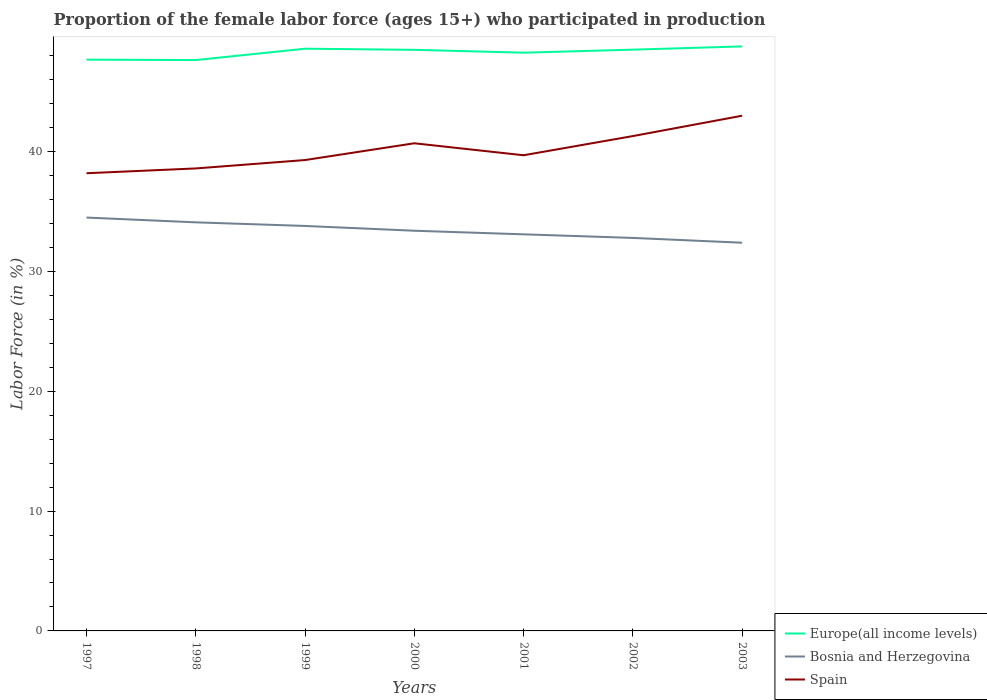How many different coloured lines are there?
Your response must be concise. 3. Across all years, what is the maximum proportion of the female labor force who participated in production in Spain?
Make the answer very short. 38.2. What is the total proportion of the female labor force who participated in production in Bosnia and Herzegovina in the graph?
Give a very brief answer. 0.3. What is the difference between the highest and the second highest proportion of the female labor force who participated in production in Europe(all income levels)?
Provide a succinct answer. 1.14. Is the proportion of the female labor force who participated in production in Bosnia and Herzegovina strictly greater than the proportion of the female labor force who participated in production in Spain over the years?
Provide a succinct answer. Yes. How many lines are there?
Provide a short and direct response. 3. What is the difference between two consecutive major ticks on the Y-axis?
Your answer should be compact. 10. Does the graph contain grids?
Keep it short and to the point. No. Where does the legend appear in the graph?
Offer a very short reply. Bottom right. How many legend labels are there?
Provide a short and direct response. 3. What is the title of the graph?
Make the answer very short. Proportion of the female labor force (ages 15+) who participated in production. What is the label or title of the Y-axis?
Provide a succinct answer. Labor Force (in %). What is the Labor Force (in %) in Europe(all income levels) in 1997?
Offer a very short reply. 47.68. What is the Labor Force (in %) in Bosnia and Herzegovina in 1997?
Offer a terse response. 34.5. What is the Labor Force (in %) in Spain in 1997?
Your answer should be very brief. 38.2. What is the Labor Force (in %) in Europe(all income levels) in 1998?
Your answer should be very brief. 47.65. What is the Labor Force (in %) of Bosnia and Herzegovina in 1998?
Provide a succinct answer. 34.1. What is the Labor Force (in %) in Spain in 1998?
Offer a very short reply. 38.6. What is the Labor Force (in %) in Europe(all income levels) in 1999?
Offer a very short reply. 48.59. What is the Labor Force (in %) of Bosnia and Herzegovina in 1999?
Offer a very short reply. 33.8. What is the Labor Force (in %) of Spain in 1999?
Provide a succinct answer. 39.3. What is the Labor Force (in %) in Europe(all income levels) in 2000?
Make the answer very short. 48.5. What is the Labor Force (in %) in Bosnia and Herzegovina in 2000?
Your answer should be very brief. 33.4. What is the Labor Force (in %) of Spain in 2000?
Your response must be concise. 40.7. What is the Labor Force (in %) in Europe(all income levels) in 2001?
Provide a short and direct response. 48.26. What is the Labor Force (in %) in Bosnia and Herzegovina in 2001?
Make the answer very short. 33.1. What is the Labor Force (in %) of Spain in 2001?
Make the answer very short. 39.7. What is the Labor Force (in %) of Europe(all income levels) in 2002?
Give a very brief answer. 48.51. What is the Labor Force (in %) in Bosnia and Herzegovina in 2002?
Keep it short and to the point. 32.8. What is the Labor Force (in %) of Spain in 2002?
Provide a short and direct response. 41.3. What is the Labor Force (in %) of Europe(all income levels) in 2003?
Give a very brief answer. 48.79. What is the Labor Force (in %) of Bosnia and Herzegovina in 2003?
Provide a succinct answer. 32.4. Across all years, what is the maximum Labor Force (in %) of Europe(all income levels)?
Make the answer very short. 48.79. Across all years, what is the maximum Labor Force (in %) of Bosnia and Herzegovina?
Ensure brevity in your answer.  34.5. Across all years, what is the minimum Labor Force (in %) in Europe(all income levels)?
Offer a terse response. 47.65. Across all years, what is the minimum Labor Force (in %) in Bosnia and Herzegovina?
Make the answer very short. 32.4. Across all years, what is the minimum Labor Force (in %) in Spain?
Your answer should be very brief. 38.2. What is the total Labor Force (in %) in Europe(all income levels) in the graph?
Ensure brevity in your answer.  337.98. What is the total Labor Force (in %) of Bosnia and Herzegovina in the graph?
Your answer should be very brief. 234.1. What is the total Labor Force (in %) of Spain in the graph?
Ensure brevity in your answer.  280.8. What is the difference between the Labor Force (in %) of Europe(all income levels) in 1997 and that in 1998?
Keep it short and to the point. 0.04. What is the difference between the Labor Force (in %) in Bosnia and Herzegovina in 1997 and that in 1998?
Your response must be concise. 0.4. What is the difference between the Labor Force (in %) of Europe(all income levels) in 1997 and that in 1999?
Offer a very short reply. -0.91. What is the difference between the Labor Force (in %) of Spain in 1997 and that in 1999?
Ensure brevity in your answer.  -1.1. What is the difference between the Labor Force (in %) of Europe(all income levels) in 1997 and that in 2000?
Provide a succinct answer. -0.82. What is the difference between the Labor Force (in %) of Spain in 1997 and that in 2000?
Your response must be concise. -2.5. What is the difference between the Labor Force (in %) in Europe(all income levels) in 1997 and that in 2001?
Make the answer very short. -0.58. What is the difference between the Labor Force (in %) of Bosnia and Herzegovina in 1997 and that in 2001?
Provide a succinct answer. 1.4. What is the difference between the Labor Force (in %) of Europe(all income levels) in 1997 and that in 2002?
Provide a short and direct response. -0.83. What is the difference between the Labor Force (in %) in Bosnia and Herzegovina in 1997 and that in 2002?
Provide a succinct answer. 1.7. What is the difference between the Labor Force (in %) of Spain in 1997 and that in 2002?
Offer a very short reply. -3.1. What is the difference between the Labor Force (in %) in Europe(all income levels) in 1997 and that in 2003?
Make the answer very short. -1.11. What is the difference between the Labor Force (in %) of Europe(all income levels) in 1998 and that in 1999?
Your answer should be very brief. -0.95. What is the difference between the Labor Force (in %) in Bosnia and Herzegovina in 1998 and that in 1999?
Make the answer very short. 0.3. What is the difference between the Labor Force (in %) of Europe(all income levels) in 1998 and that in 2000?
Provide a succinct answer. -0.85. What is the difference between the Labor Force (in %) in Europe(all income levels) in 1998 and that in 2001?
Keep it short and to the point. -0.62. What is the difference between the Labor Force (in %) of Europe(all income levels) in 1998 and that in 2002?
Provide a succinct answer. -0.87. What is the difference between the Labor Force (in %) of Spain in 1998 and that in 2002?
Offer a terse response. -2.7. What is the difference between the Labor Force (in %) of Europe(all income levels) in 1998 and that in 2003?
Keep it short and to the point. -1.14. What is the difference between the Labor Force (in %) of Spain in 1998 and that in 2003?
Provide a short and direct response. -4.4. What is the difference between the Labor Force (in %) of Europe(all income levels) in 1999 and that in 2000?
Make the answer very short. 0.1. What is the difference between the Labor Force (in %) in Europe(all income levels) in 1999 and that in 2001?
Keep it short and to the point. 0.33. What is the difference between the Labor Force (in %) of Spain in 1999 and that in 2001?
Your answer should be very brief. -0.4. What is the difference between the Labor Force (in %) in Europe(all income levels) in 1999 and that in 2002?
Provide a succinct answer. 0.08. What is the difference between the Labor Force (in %) in Bosnia and Herzegovina in 1999 and that in 2002?
Offer a terse response. 1. What is the difference between the Labor Force (in %) in Europe(all income levels) in 1999 and that in 2003?
Provide a succinct answer. -0.19. What is the difference between the Labor Force (in %) in Bosnia and Herzegovina in 1999 and that in 2003?
Ensure brevity in your answer.  1.4. What is the difference between the Labor Force (in %) of Spain in 1999 and that in 2003?
Make the answer very short. -3.7. What is the difference between the Labor Force (in %) of Europe(all income levels) in 2000 and that in 2001?
Offer a terse response. 0.24. What is the difference between the Labor Force (in %) in Bosnia and Herzegovina in 2000 and that in 2001?
Offer a terse response. 0.3. What is the difference between the Labor Force (in %) of Spain in 2000 and that in 2001?
Your response must be concise. 1. What is the difference between the Labor Force (in %) in Europe(all income levels) in 2000 and that in 2002?
Make the answer very short. -0.02. What is the difference between the Labor Force (in %) of Bosnia and Herzegovina in 2000 and that in 2002?
Give a very brief answer. 0.6. What is the difference between the Labor Force (in %) of Spain in 2000 and that in 2002?
Ensure brevity in your answer.  -0.6. What is the difference between the Labor Force (in %) in Europe(all income levels) in 2000 and that in 2003?
Ensure brevity in your answer.  -0.29. What is the difference between the Labor Force (in %) of Spain in 2000 and that in 2003?
Provide a succinct answer. -2.3. What is the difference between the Labor Force (in %) in Europe(all income levels) in 2001 and that in 2002?
Make the answer very short. -0.25. What is the difference between the Labor Force (in %) of Bosnia and Herzegovina in 2001 and that in 2002?
Give a very brief answer. 0.3. What is the difference between the Labor Force (in %) in Europe(all income levels) in 2001 and that in 2003?
Give a very brief answer. -0.52. What is the difference between the Labor Force (in %) of Bosnia and Herzegovina in 2001 and that in 2003?
Your answer should be very brief. 0.7. What is the difference between the Labor Force (in %) of Spain in 2001 and that in 2003?
Give a very brief answer. -3.3. What is the difference between the Labor Force (in %) of Europe(all income levels) in 2002 and that in 2003?
Offer a very short reply. -0.27. What is the difference between the Labor Force (in %) of Europe(all income levels) in 1997 and the Labor Force (in %) of Bosnia and Herzegovina in 1998?
Offer a terse response. 13.58. What is the difference between the Labor Force (in %) in Europe(all income levels) in 1997 and the Labor Force (in %) in Spain in 1998?
Your response must be concise. 9.08. What is the difference between the Labor Force (in %) in Europe(all income levels) in 1997 and the Labor Force (in %) in Bosnia and Herzegovina in 1999?
Give a very brief answer. 13.88. What is the difference between the Labor Force (in %) in Europe(all income levels) in 1997 and the Labor Force (in %) in Spain in 1999?
Ensure brevity in your answer.  8.38. What is the difference between the Labor Force (in %) of Bosnia and Herzegovina in 1997 and the Labor Force (in %) of Spain in 1999?
Make the answer very short. -4.8. What is the difference between the Labor Force (in %) in Europe(all income levels) in 1997 and the Labor Force (in %) in Bosnia and Herzegovina in 2000?
Your answer should be compact. 14.28. What is the difference between the Labor Force (in %) of Europe(all income levels) in 1997 and the Labor Force (in %) of Spain in 2000?
Offer a very short reply. 6.98. What is the difference between the Labor Force (in %) of Europe(all income levels) in 1997 and the Labor Force (in %) of Bosnia and Herzegovina in 2001?
Make the answer very short. 14.58. What is the difference between the Labor Force (in %) of Europe(all income levels) in 1997 and the Labor Force (in %) of Spain in 2001?
Offer a terse response. 7.98. What is the difference between the Labor Force (in %) of Europe(all income levels) in 1997 and the Labor Force (in %) of Bosnia and Herzegovina in 2002?
Give a very brief answer. 14.88. What is the difference between the Labor Force (in %) of Europe(all income levels) in 1997 and the Labor Force (in %) of Spain in 2002?
Give a very brief answer. 6.38. What is the difference between the Labor Force (in %) in Europe(all income levels) in 1997 and the Labor Force (in %) in Bosnia and Herzegovina in 2003?
Keep it short and to the point. 15.28. What is the difference between the Labor Force (in %) of Europe(all income levels) in 1997 and the Labor Force (in %) of Spain in 2003?
Your answer should be very brief. 4.68. What is the difference between the Labor Force (in %) of Europe(all income levels) in 1998 and the Labor Force (in %) of Bosnia and Herzegovina in 1999?
Make the answer very short. 13.85. What is the difference between the Labor Force (in %) of Europe(all income levels) in 1998 and the Labor Force (in %) of Spain in 1999?
Your answer should be compact. 8.35. What is the difference between the Labor Force (in %) in Bosnia and Herzegovina in 1998 and the Labor Force (in %) in Spain in 1999?
Offer a terse response. -5.2. What is the difference between the Labor Force (in %) in Europe(all income levels) in 1998 and the Labor Force (in %) in Bosnia and Herzegovina in 2000?
Keep it short and to the point. 14.25. What is the difference between the Labor Force (in %) in Europe(all income levels) in 1998 and the Labor Force (in %) in Spain in 2000?
Keep it short and to the point. 6.95. What is the difference between the Labor Force (in %) in Europe(all income levels) in 1998 and the Labor Force (in %) in Bosnia and Herzegovina in 2001?
Your answer should be very brief. 14.55. What is the difference between the Labor Force (in %) in Europe(all income levels) in 1998 and the Labor Force (in %) in Spain in 2001?
Provide a short and direct response. 7.95. What is the difference between the Labor Force (in %) in Europe(all income levels) in 1998 and the Labor Force (in %) in Bosnia and Herzegovina in 2002?
Ensure brevity in your answer.  14.85. What is the difference between the Labor Force (in %) in Europe(all income levels) in 1998 and the Labor Force (in %) in Spain in 2002?
Make the answer very short. 6.35. What is the difference between the Labor Force (in %) in Bosnia and Herzegovina in 1998 and the Labor Force (in %) in Spain in 2002?
Keep it short and to the point. -7.2. What is the difference between the Labor Force (in %) of Europe(all income levels) in 1998 and the Labor Force (in %) of Bosnia and Herzegovina in 2003?
Your answer should be compact. 15.25. What is the difference between the Labor Force (in %) of Europe(all income levels) in 1998 and the Labor Force (in %) of Spain in 2003?
Keep it short and to the point. 4.65. What is the difference between the Labor Force (in %) of Bosnia and Herzegovina in 1998 and the Labor Force (in %) of Spain in 2003?
Make the answer very short. -8.9. What is the difference between the Labor Force (in %) of Europe(all income levels) in 1999 and the Labor Force (in %) of Bosnia and Herzegovina in 2000?
Keep it short and to the point. 15.19. What is the difference between the Labor Force (in %) in Europe(all income levels) in 1999 and the Labor Force (in %) in Spain in 2000?
Give a very brief answer. 7.89. What is the difference between the Labor Force (in %) in Bosnia and Herzegovina in 1999 and the Labor Force (in %) in Spain in 2000?
Your response must be concise. -6.9. What is the difference between the Labor Force (in %) in Europe(all income levels) in 1999 and the Labor Force (in %) in Bosnia and Herzegovina in 2001?
Ensure brevity in your answer.  15.49. What is the difference between the Labor Force (in %) in Europe(all income levels) in 1999 and the Labor Force (in %) in Spain in 2001?
Offer a terse response. 8.89. What is the difference between the Labor Force (in %) in Bosnia and Herzegovina in 1999 and the Labor Force (in %) in Spain in 2001?
Offer a terse response. -5.9. What is the difference between the Labor Force (in %) of Europe(all income levels) in 1999 and the Labor Force (in %) of Bosnia and Herzegovina in 2002?
Ensure brevity in your answer.  15.79. What is the difference between the Labor Force (in %) in Europe(all income levels) in 1999 and the Labor Force (in %) in Spain in 2002?
Offer a very short reply. 7.29. What is the difference between the Labor Force (in %) in Europe(all income levels) in 1999 and the Labor Force (in %) in Bosnia and Herzegovina in 2003?
Keep it short and to the point. 16.19. What is the difference between the Labor Force (in %) in Europe(all income levels) in 1999 and the Labor Force (in %) in Spain in 2003?
Your answer should be compact. 5.59. What is the difference between the Labor Force (in %) of Europe(all income levels) in 2000 and the Labor Force (in %) of Bosnia and Herzegovina in 2001?
Keep it short and to the point. 15.4. What is the difference between the Labor Force (in %) of Europe(all income levels) in 2000 and the Labor Force (in %) of Spain in 2001?
Provide a short and direct response. 8.8. What is the difference between the Labor Force (in %) in Europe(all income levels) in 2000 and the Labor Force (in %) in Bosnia and Herzegovina in 2002?
Offer a very short reply. 15.7. What is the difference between the Labor Force (in %) of Europe(all income levels) in 2000 and the Labor Force (in %) of Spain in 2002?
Ensure brevity in your answer.  7.2. What is the difference between the Labor Force (in %) of Bosnia and Herzegovina in 2000 and the Labor Force (in %) of Spain in 2002?
Offer a very short reply. -7.9. What is the difference between the Labor Force (in %) of Europe(all income levels) in 2000 and the Labor Force (in %) of Bosnia and Herzegovina in 2003?
Provide a short and direct response. 16.1. What is the difference between the Labor Force (in %) in Europe(all income levels) in 2000 and the Labor Force (in %) in Spain in 2003?
Your answer should be compact. 5.5. What is the difference between the Labor Force (in %) of Europe(all income levels) in 2001 and the Labor Force (in %) of Bosnia and Herzegovina in 2002?
Your answer should be very brief. 15.46. What is the difference between the Labor Force (in %) of Europe(all income levels) in 2001 and the Labor Force (in %) of Spain in 2002?
Provide a short and direct response. 6.96. What is the difference between the Labor Force (in %) of Europe(all income levels) in 2001 and the Labor Force (in %) of Bosnia and Herzegovina in 2003?
Your answer should be very brief. 15.86. What is the difference between the Labor Force (in %) in Europe(all income levels) in 2001 and the Labor Force (in %) in Spain in 2003?
Make the answer very short. 5.26. What is the difference between the Labor Force (in %) of Europe(all income levels) in 2002 and the Labor Force (in %) of Bosnia and Herzegovina in 2003?
Your answer should be compact. 16.11. What is the difference between the Labor Force (in %) in Europe(all income levels) in 2002 and the Labor Force (in %) in Spain in 2003?
Your response must be concise. 5.51. What is the average Labor Force (in %) in Europe(all income levels) per year?
Offer a terse response. 48.28. What is the average Labor Force (in %) in Bosnia and Herzegovina per year?
Make the answer very short. 33.44. What is the average Labor Force (in %) in Spain per year?
Your answer should be compact. 40.11. In the year 1997, what is the difference between the Labor Force (in %) in Europe(all income levels) and Labor Force (in %) in Bosnia and Herzegovina?
Offer a very short reply. 13.18. In the year 1997, what is the difference between the Labor Force (in %) of Europe(all income levels) and Labor Force (in %) of Spain?
Provide a short and direct response. 9.48. In the year 1998, what is the difference between the Labor Force (in %) of Europe(all income levels) and Labor Force (in %) of Bosnia and Herzegovina?
Ensure brevity in your answer.  13.55. In the year 1998, what is the difference between the Labor Force (in %) in Europe(all income levels) and Labor Force (in %) in Spain?
Your answer should be compact. 9.05. In the year 1998, what is the difference between the Labor Force (in %) of Bosnia and Herzegovina and Labor Force (in %) of Spain?
Your answer should be compact. -4.5. In the year 1999, what is the difference between the Labor Force (in %) of Europe(all income levels) and Labor Force (in %) of Bosnia and Herzegovina?
Keep it short and to the point. 14.79. In the year 1999, what is the difference between the Labor Force (in %) of Europe(all income levels) and Labor Force (in %) of Spain?
Your answer should be compact. 9.29. In the year 1999, what is the difference between the Labor Force (in %) of Bosnia and Herzegovina and Labor Force (in %) of Spain?
Your answer should be very brief. -5.5. In the year 2000, what is the difference between the Labor Force (in %) in Europe(all income levels) and Labor Force (in %) in Bosnia and Herzegovina?
Make the answer very short. 15.1. In the year 2000, what is the difference between the Labor Force (in %) in Europe(all income levels) and Labor Force (in %) in Spain?
Your answer should be very brief. 7.8. In the year 2000, what is the difference between the Labor Force (in %) of Bosnia and Herzegovina and Labor Force (in %) of Spain?
Make the answer very short. -7.3. In the year 2001, what is the difference between the Labor Force (in %) of Europe(all income levels) and Labor Force (in %) of Bosnia and Herzegovina?
Make the answer very short. 15.16. In the year 2001, what is the difference between the Labor Force (in %) in Europe(all income levels) and Labor Force (in %) in Spain?
Provide a succinct answer. 8.56. In the year 2001, what is the difference between the Labor Force (in %) in Bosnia and Herzegovina and Labor Force (in %) in Spain?
Ensure brevity in your answer.  -6.6. In the year 2002, what is the difference between the Labor Force (in %) in Europe(all income levels) and Labor Force (in %) in Bosnia and Herzegovina?
Offer a terse response. 15.71. In the year 2002, what is the difference between the Labor Force (in %) of Europe(all income levels) and Labor Force (in %) of Spain?
Provide a short and direct response. 7.21. In the year 2002, what is the difference between the Labor Force (in %) in Bosnia and Herzegovina and Labor Force (in %) in Spain?
Provide a short and direct response. -8.5. In the year 2003, what is the difference between the Labor Force (in %) of Europe(all income levels) and Labor Force (in %) of Bosnia and Herzegovina?
Offer a very short reply. 16.39. In the year 2003, what is the difference between the Labor Force (in %) in Europe(all income levels) and Labor Force (in %) in Spain?
Your response must be concise. 5.79. What is the ratio of the Labor Force (in %) in Bosnia and Herzegovina in 1997 to that in 1998?
Your response must be concise. 1.01. What is the ratio of the Labor Force (in %) in Europe(all income levels) in 1997 to that in 1999?
Provide a short and direct response. 0.98. What is the ratio of the Labor Force (in %) of Bosnia and Herzegovina in 1997 to that in 1999?
Make the answer very short. 1.02. What is the ratio of the Labor Force (in %) in Spain in 1997 to that in 1999?
Offer a terse response. 0.97. What is the ratio of the Labor Force (in %) in Europe(all income levels) in 1997 to that in 2000?
Offer a terse response. 0.98. What is the ratio of the Labor Force (in %) of Bosnia and Herzegovina in 1997 to that in 2000?
Your answer should be very brief. 1.03. What is the ratio of the Labor Force (in %) in Spain in 1997 to that in 2000?
Your answer should be very brief. 0.94. What is the ratio of the Labor Force (in %) of Bosnia and Herzegovina in 1997 to that in 2001?
Provide a short and direct response. 1.04. What is the ratio of the Labor Force (in %) of Spain in 1997 to that in 2001?
Your answer should be compact. 0.96. What is the ratio of the Labor Force (in %) in Europe(all income levels) in 1997 to that in 2002?
Offer a very short reply. 0.98. What is the ratio of the Labor Force (in %) in Bosnia and Herzegovina in 1997 to that in 2002?
Offer a terse response. 1.05. What is the ratio of the Labor Force (in %) of Spain in 1997 to that in 2002?
Offer a terse response. 0.92. What is the ratio of the Labor Force (in %) in Europe(all income levels) in 1997 to that in 2003?
Make the answer very short. 0.98. What is the ratio of the Labor Force (in %) of Bosnia and Herzegovina in 1997 to that in 2003?
Ensure brevity in your answer.  1.06. What is the ratio of the Labor Force (in %) in Spain in 1997 to that in 2003?
Offer a terse response. 0.89. What is the ratio of the Labor Force (in %) of Europe(all income levels) in 1998 to that in 1999?
Make the answer very short. 0.98. What is the ratio of the Labor Force (in %) in Bosnia and Herzegovina in 1998 to that in 1999?
Provide a succinct answer. 1.01. What is the ratio of the Labor Force (in %) in Spain in 1998 to that in 1999?
Your answer should be very brief. 0.98. What is the ratio of the Labor Force (in %) of Europe(all income levels) in 1998 to that in 2000?
Keep it short and to the point. 0.98. What is the ratio of the Labor Force (in %) of Bosnia and Herzegovina in 1998 to that in 2000?
Give a very brief answer. 1.02. What is the ratio of the Labor Force (in %) of Spain in 1998 to that in 2000?
Ensure brevity in your answer.  0.95. What is the ratio of the Labor Force (in %) of Europe(all income levels) in 1998 to that in 2001?
Ensure brevity in your answer.  0.99. What is the ratio of the Labor Force (in %) of Bosnia and Herzegovina in 1998 to that in 2001?
Your answer should be compact. 1.03. What is the ratio of the Labor Force (in %) in Spain in 1998 to that in 2001?
Make the answer very short. 0.97. What is the ratio of the Labor Force (in %) of Europe(all income levels) in 1998 to that in 2002?
Ensure brevity in your answer.  0.98. What is the ratio of the Labor Force (in %) of Bosnia and Herzegovina in 1998 to that in 2002?
Provide a short and direct response. 1.04. What is the ratio of the Labor Force (in %) in Spain in 1998 to that in 2002?
Your answer should be very brief. 0.93. What is the ratio of the Labor Force (in %) in Europe(all income levels) in 1998 to that in 2003?
Your answer should be compact. 0.98. What is the ratio of the Labor Force (in %) in Bosnia and Herzegovina in 1998 to that in 2003?
Keep it short and to the point. 1.05. What is the ratio of the Labor Force (in %) in Spain in 1998 to that in 2003?
Provide a short and direct response. 0.9. What is the ratio of the Labor Force (in %) of Bosnia and Herzegovina in 1999 to that in 2000?
Your answer should be compact. 1.01. What is the ratio of the Labor Force (in %) of Spain in 1999 to that in 2000?
Ensure brevity in your answer.  0.97. What is the ratio of the Labor Force (in %) in Europe(all income levels) in 1999 to that in 2001?
Make the answer very short. 1.01. What is the ratio of the Labor Force (in %) of Bosnia and Herzegovina in 1999 to that in 2001?
Offer a terse response. 1.02. What is the ratio of the Labor Force (in %) of Spain in 1999 to that in 2001?
Provide a short and direct response. 0.99. What is the ratio of the Labor Force (in %) in Bosnia and Herzegovina in 1999 to that in 2002?
Provide a short and direct response. 1.03. What is the ratio of the Labor Force (in %) in Spain in 1999 to that in 2002?
Your answer should be compact. 0.95. What is the ratio of the Labor Force (in %) of Europe(all income levels) in 1999 to that in 2003?
Your response must be concise. 1. What is the ratio of the Labor Force (in %) in Bosnia and Herzegovina in 1999 to that in 2003?
Offer a terse response. 1.04. What is the ratio of the Labor Force (in %) of Spain in 1999 to that in 2003?
Your answer should be compact. 0.91. What is the ratio of the Labor Force (in %) in Bosnia and Herzegovina in 2000 to that in 2001?
Your answer should be compact. 1.01. What is the ratio of the Labor Force (in %) of Spain in 2000 to that in 2001?
Make the answer very short. 1.03. What is the ratio of the Labor Force (in %) in Bosnia and Herzegovina in 2000 to that in 2002?
Keep it short and to the point. 1.02. What is the ratio of the Labor Force (in %) of Spain in 2000 to that in 2002?
Provide a succinct answer. 0.99. What is the ratio of the Labor Force (in %) in Bosnia and Herzegovina in 2000 to that in 2003?
Provide a short and direct response. 1.03. What is the ratio of the Labor Force (in %) of Spain in 2000 to that in 2003?
Provide a short and direct response. 0.95. What is the ratio of the Labor Force (in %) of Europe(all income levels) in 2001 to that in 2002?
Provide a succinct answer. 0.99. What is the ratio of the Labor Force (in %) of Bosnia and Herzegovina in 2001 to that in 2002?
Offer a very short reply. 1.01. What is the ratio of the Labor Force (in %) of Spain in 2001 to that in 2002?
Keep it short and to the point. 0.96. What is the ratio of the Labor Force (in %) in Bosnia and Herzegovina in 2001 to that in 2003?
Offer a very short reply. 1.02. What is the ratio of the Labor Force (in %) in Spain in 2001 to that in 2003?
Offer a terse response. 0.92. What is the ratio of the Labor Force (in %) of Europe(all income levels) in 2002 to that in 2003?
Provide a short and direct response. 0.99. What is the ratio of the Labor Force (in %) in Bosnia and Herzegovina in 2002 to that in 2003?
Keep it short and to the point. 1.01. What is the ratio of the Labor Force (in %) in Spain in 2002 to that in 2003?
Provide a short and direct response. 0.96. What is the difference between the highest and the second highest Labor Force (in %) in Europe(all income levels)?
Make the answer very short. 0.19. What is the difference between the highest and the second highest Labor Force (in %) of Bosnia and Herzegovina?
Give a very brief answer. 0.4. What is the difference between the highest and the lowest Labor Force (in %) of Europe(all income levels)?
Your response must be concise. 1.14. 